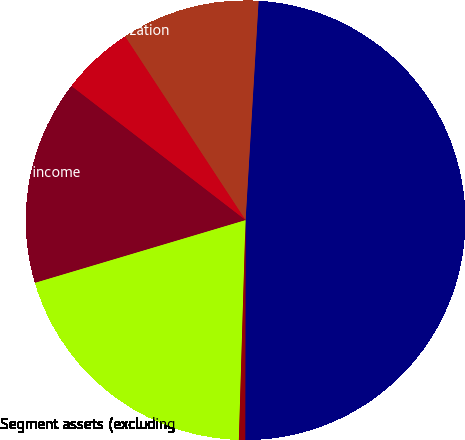Convert chart. <chart><loc_0><loc_0><loc_500><loc_500><pie_chart><fcel>-external<fcel>-intersegment<fcel>Depreciation and amortization<fcel>Segment operating income<fcel>Segment assets (excluding<fcel>Additions to property plant<nl><fcel>49.08%<fcel>10.18%<fcel>5.32%<fcel>15.05%<fcel>19.91%<fcel>0.46%<nl></chart> 